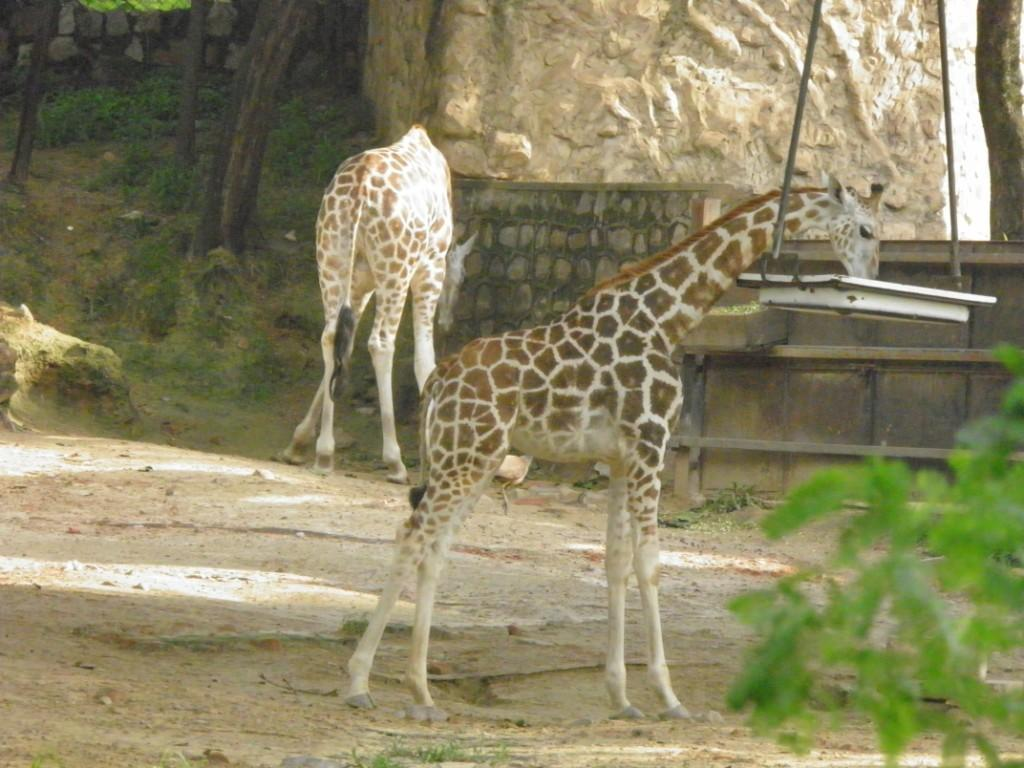What animals can be seen in the image? There are giraffes in the image. What type of structure is visible in the background of the image? There is a brick wall in the background of the image. What is hanging on the right side of the image? There is a vessel hanged with ropes on the right side of the image. What type of vegetation can be seen in the background of the image? There are trees in the background of the image. Where are the fairies hiding in the image? There are no fairies present in the image. What type of toy can be seen in the image? There are no toys present in the image. 